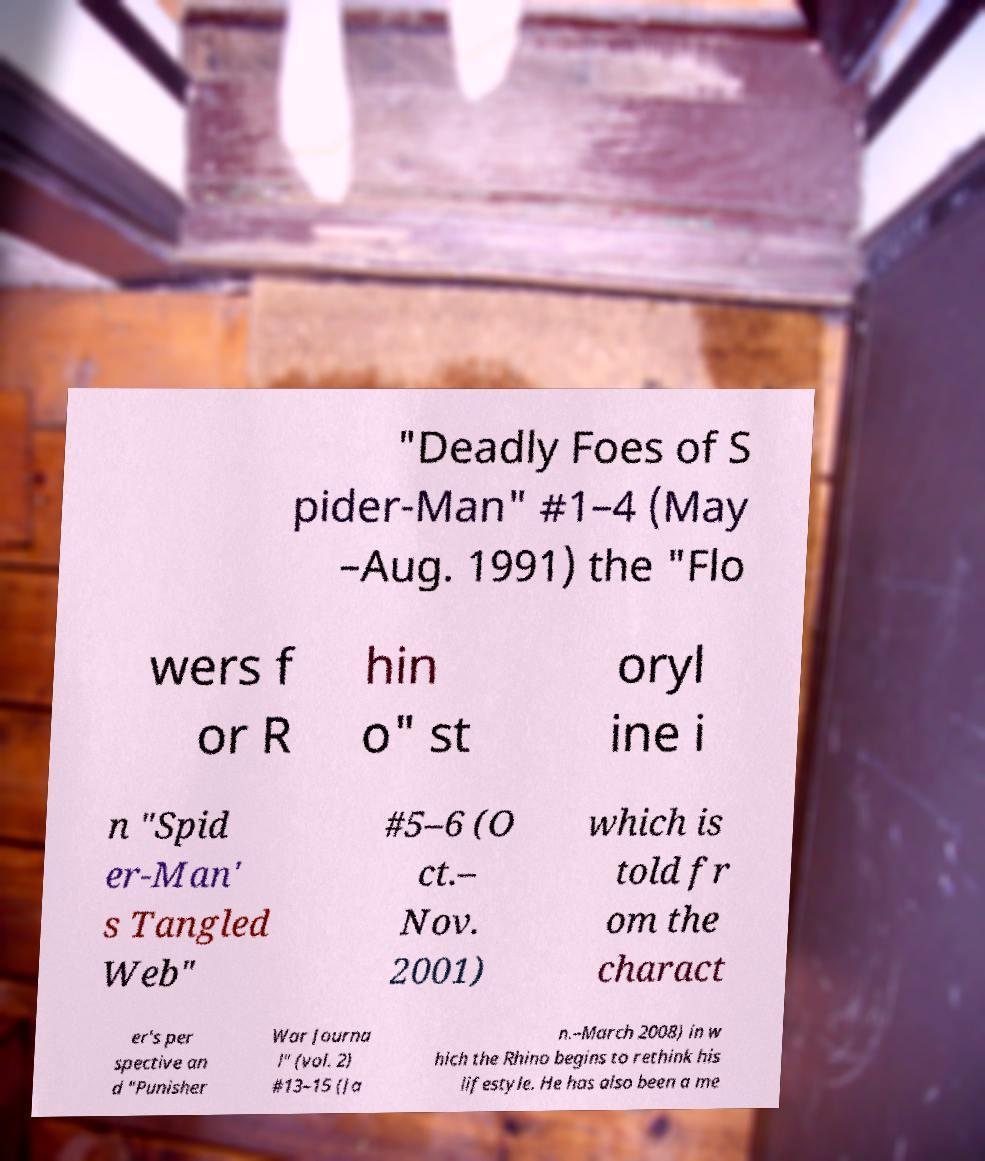Please identify and transcribe the text found in this image. "Deadly Foes of S pider-Man" #1–4 (May –Aug. 1991) the "Flo wers f or R hin o" st oryl ine i n "Spid er-Man' s Tangled Web" #5–6 (O ct.– Nov. 2001) which is told fr om the charact er's per spective an d "Punisher War Journa l" (vol. 2) #13–15 (Ja n.–March 2008) in w hich the Rhino begins to rethink his lifestyle. He has also been a me 